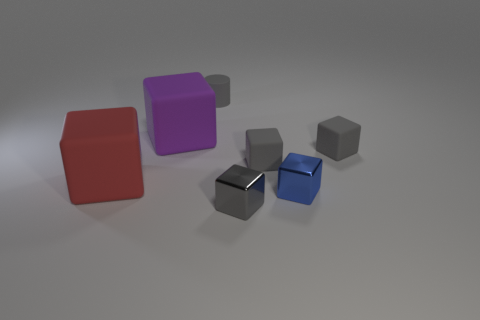How many gray blocks must be subtracted to get 1 gray blocks? 2 Subtract all tiny metallic cubes. How many cubes are left? 4 Add 1 big red things. How many objects exist? 8 Subtract all red blocks. How many blocks are left? 5 Subtract 0 yellow spheres. How many objects are left? 7 Subtract all blocks. How many objects are left? 1 Subtract 1 cubes. How many cubes are left? 5 Subtract all cyan blocks. Subtract all brown spheres. How many blocks are left? 6 Subtract all cyan cubes. How many purple cylinders are left? 0 Subtract all matte things. Subtract all large metal cylinders. How many objects are left? 2 